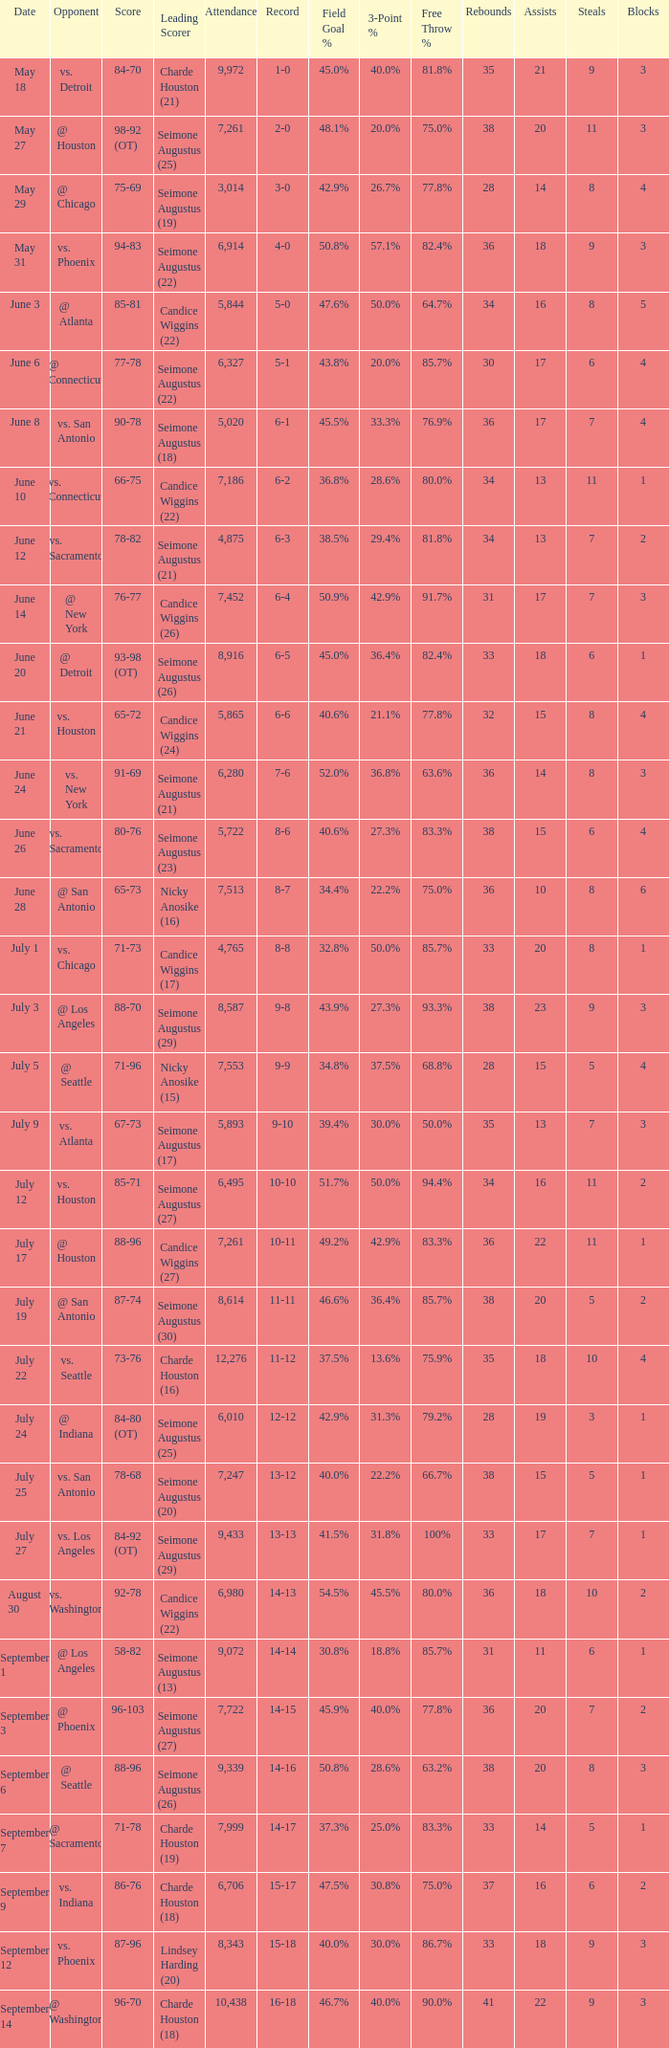Which Attendance has a Date of september 7? 7999.0. 